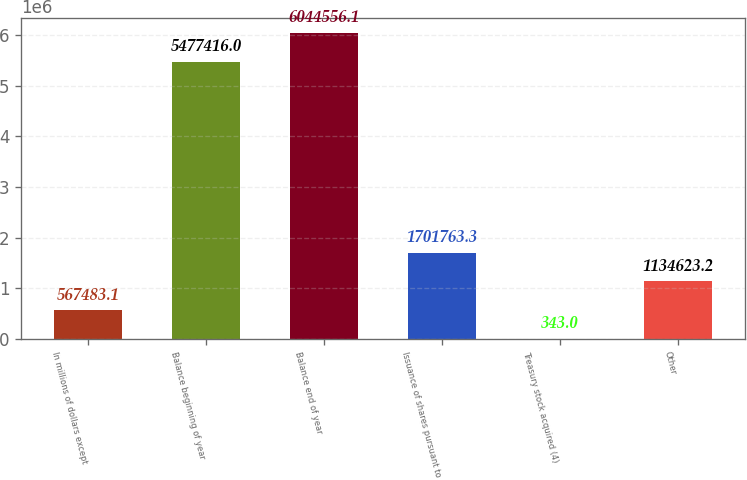<chart> <loc_0><loc_0><loc_500><loc_500><bar_chart><fcel>In millions of dollars except<fcel>Balance beginning of year<fcel>Balance end of year<fcel>Issuance of shares pursuant to<fcel>Treasury stock acquired (4)<fcel>Other<nl><fcel>567483<fcel>5.47742e+06<fcel>6.04456e+06<fcel>1.70176e+06<fcel>343<fcel>1.13462e+06<nl></chart> 